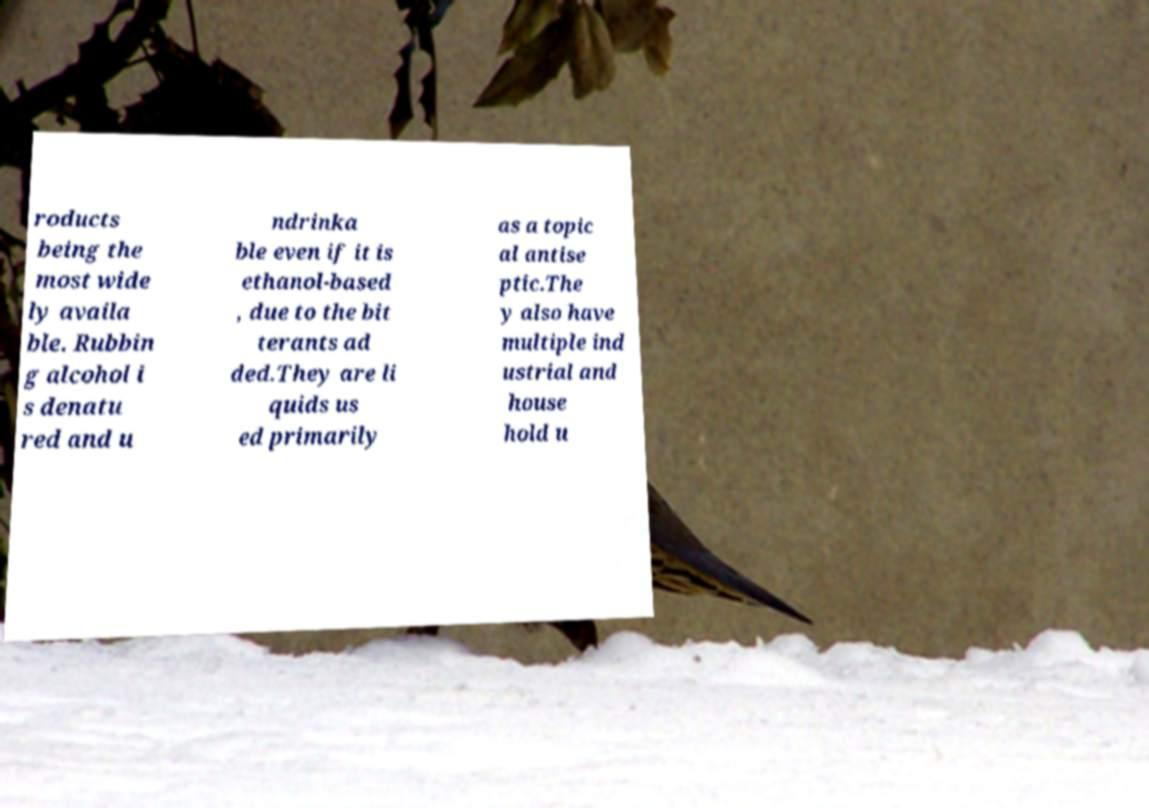Can you read and provide the text displayed in the image?This photo seems to have some interesting text. Can you extract and type it out for me? roducts being the most wide ly availa ble. Rubbin g alcohol i s denatu red and u ndrinka ble even if it is ethanol-based , due to the bit terants ad ded.They are li quids us ed primarily as a topic al antise ptic.The y also have multiple ind ustrial and house hold u 